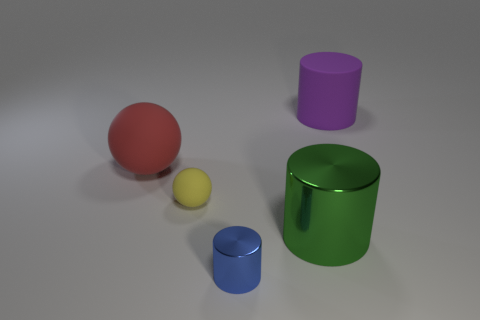Do the large rubber thing on the left side of the small yellow thing and the big purple matte object have the same shape?
Offer a terse response. No. What is the cylinder behind the big green metallic object made of?
Your answer should be compact. Rubber. Is there a cyan cylinder made of the same material as the green thing?
Provide a short and direct response. No. What size is the purple matte thing?
Keep it short and to the point. Large. What number of cyan things are either rubber cubes or small metal things?
Provide a short and direct response. 0. What number of other rubber things are the same shape as the yellow matte thing?
Give a very brief answer. 1. How many blue objects are the same size as the green metallic object?
Your answer should be compact. 0. There is another small object that is the same shape as the green object; what is it made of?
Give a very brief answer. Metal. The metallic cylinder that is behind the blue thing is what color?
Ensure brevity in your answer.  Green. Are there more yellow things that are in front of the large purple cylinder than tiny green metal balls?
Make the answer very short. Yes. 